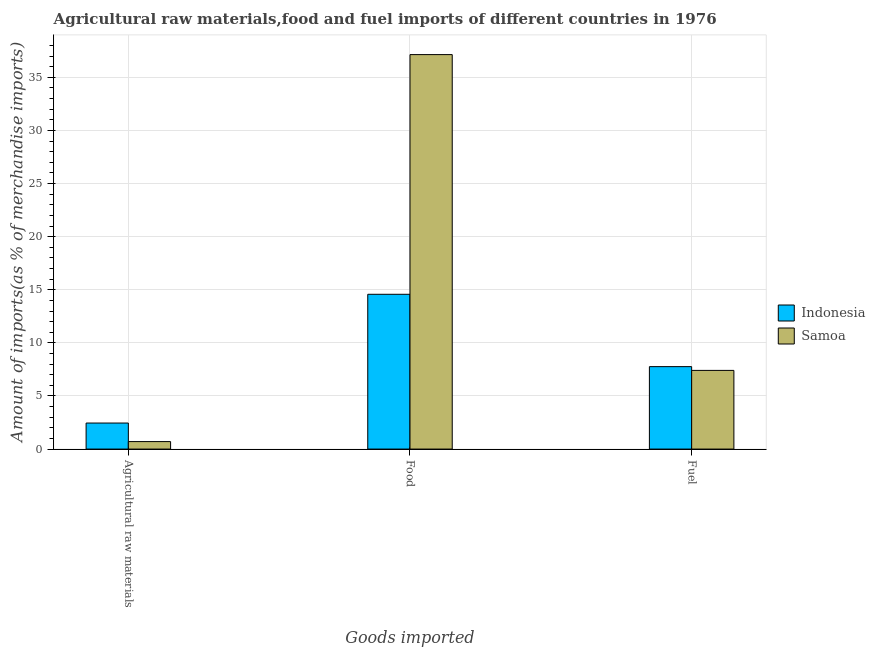How many different coloured bars are there?
Your response must be concise. 2. How many groups of bars are there?
Provide a short and direct response. 3. Are the number of bars per tick equal to the number of legend labels?
Make the answer very short. Yes. How many bars are there on the 2nd tick from the right?
Keep it short and to the point. 2. What is the label of the 2nd group of bars from the left?
Provide a short and direct response. Food. What is the percentage of fuel imports in Samoa?
Provide a short and direct response. 7.41. Across all countries, what is the maximum percentage of raw materials imports?
Provide a short and direct response. 2.45. Across all countries, what is the minimum percentage of fuel imports?
Your answer should be very brief. 7.41. In which country was the percentage of food imports maximum?
Offer a very short reply. Samoa. In which country was the percentage of fuel imports minimum?
Offer a very short reply. Samoa. What is the total percentage of fuel imports in the graph?
Give a very brief answer. 15.17. What is the difference between the percentage of raw materials imports in Samoa and that in Indonesia?
Your response must be concise. -1.75. What is the difference between the percentage of raw materials imports in Samoa and the percentage of fuel imports in Indonesia?
Offer a very short reply. -7.06. What is the average percentage of fuel imports per country?
Your response must be concise. 7.58. What is the difference between the percentage of food imports and percentage of fuel imports in Indonesia?
Make the answer very short. 6.81. What is the ratio of the percentage of food imports in Samoa to that in Indonesia?
Provide a short and direct response. 2.55. Is the percentage of raw materials imports in Indonesia less than that in Samoa?
Ensure brevity in your answer.  No. What is the difference between the highest and the second highest percentage of food imports?
Offer a terse response. 22.57. What is the difference between the highest and the lowest percentage of food imports?
Provide a short and direct response. 22.57. In how many countries, is the percentage of fuel imports greater than the average percentage of fuel imports taken over all countries?
Make the answer very short. 1. Is the sum of the percentage of food imports in Indonesia and Samoa greater than the maximum percentage of raw materials imports across all countries?
Your answer should be compact. Yes. What does the 2nd bar from the left in Fuel represents?
Your response must be concise. Samoa. What does the 1st bar from the right in Food represents?
Provide a short and direct response. Samoa. How many bars are there?
Give a very brief answer. 6. What is the difference between two consecutive major ticks on the Y-axis?
Make the answer very short. 5. Are the values on the major ticks of Y-axis written in scientific E-notation?
Offer a very short reply. No. Does the graph contain grids?
Provide a succinct answer. Yes. Where does the legend appear in the graph?
Your response must be concise. Center right. How many legend labels are there?
Keep it short and to the point. 2. How are the legend labels stacked?
Your answer should be compact. Vertical. What is the title of the graph?
Your response must be concise. Agricultural raw materials,food and fuel imports of different countries in 1976. What is the label or title of the X-axis?
Keep it short and to the point. Goods imported. What is the label or title of the Y-axis?
Your response must be concise. Amount of imports(as % of merchandise imports). What is the Amount of imports(as % of merchandise imports) in Indonesia in Agricultural raw materials?
Give a very brief answer. 2.45. What is the Amount of imports(as % of merchandise imports) of Samoa in Agricultural raw materials?
Keep it short and to the point. 0.7. What is the Amount of imports(as % of merchandise imports) of Indonesia in Food?
Offer a terse response. 14.57. What is the Amount of imports(as % of merchandise imports) in Samoa in Food?
Offer a terse response. 37.14. What is the Amount of imports(as % of merchandise imports) of Indonesia in Fuel?
Your answer should be compact. 7.76. What is the Amount of imports(as % of merchandise imports) of Samoa in Fuel?
Make the answer very short. 7.41. Across all Goods imported, what is the maximum Amount of imports(as % of merchandise imports) in Indonesia?
Make the answer very short. 14.57. Across all Goods imported, what is the maximum Amount of imports(as % of merchandise imports) of Samoa?
Make the answer very short. 37.14. Across all Goods imported, what is the minimum Amount of imports(as % of merchandise imports) of Indonesia?
Make the answer very short. 2.45. Across all Goods imported, what is the minimum Amount of imports(as % of merchandise imports) of Samoa?
Offer a terse response. 0.7. What is the total Amount of imports(as % of merchandise imports) of Indonesia in the graph?
Your answer should be very brief. 24.79. What is the total Amount of imports(as % of merchandise imports) in Samoa in the graph?
Your answer should be compact. 45.25. What is the difference between the Amount of imports(as % of merchandise imports) in Indonesia in Agricultural raw materials and that in Food?
Ensure brevity in your answer.  -12.12. What is the difference between the Amount of imports(as % of merchandise imports) in Samoa in Agricultural raw materials and that in Food?
Ensure brevity in your answer.  -36.44. What is the difference between the Amount of imports(as % of merchandise imports) in Indonesia in Agricultural raw materials and that in Fuel?
Provide a succinct answer. -5.31. What is the difference between the Amount of imports(as % of merchandise imports) in Samoa in Agricultural raw materials and that in Fuel?
Offer a terse response. -6.7. What is the difference between the Amount of imports(as % of merchandise imports) in Indonesia in Food and that in Fuel?
Your answer should be very brief. 6.81. What is the difference between the Amount of imports(as % of merchandise imports) in Samoa in Food and that in Fuel?
Your answer should be very brief. 29.73. What is the difference between the Amount of imports(as % of merchandise imports) of Indonesia in Agricultural raw materials and the Amount of imports(as % of merchandise imports) of Samoa in Food?
Keep it short and to the point. -34.69. What is the difference between the Amount of imports(as % of merchandise imports) of Indonesia in Agricultural raw materials and the Amount of imports(as % of merchandise imports) of Samoa in Fuel?
Ensure brevity in your answer.  -4.96. What is the difference between the Amount of imports(as % of merchandise imports) in Indonesia in Food and the Amount of imports(as % of merchandise imports) in Samoa in Fuel?
Offer a terse response. 7.17. What is the average Amount of imports(as % of merchandise imports) in Indonesia per Goods imported?
Provide a short and direct response. 8.26. What is the average Amount of imports(as % of merchandise imports) in Samoa per Goods imported?
Ensure brevity in your answer.  15.08. What is the difference between the Amount of imports(as % of merchandise imports) of Indonesia and Amount of imports(as % of merchandise imports) of Samoa in Agricultural raw materials?
Provide a succinct answer. 1.75. What is the difference between the Amount of imports(as % of merchandise imports) in Indonesia and Amount of imports(as % of merchandise imports) in Samoa in Food?
Your answer should be compact. -22.57. What is the difference between the Amount of imports(as % of merchandise imports) in Indonesia and Amount of imports(as % of merchandise imports) in Samoa in Fuel?
Offer a terse response. 0.36. What is the ratio of the Amount of imports(as % of merchandise imports) of Indonesia in Agricultural raw materials to that in Food?
Provide a succinct answer. 0.17. What is the ratio of the Amount of imports(as % of merchandise imports) of Samoa in Agricultural raw materials to that in Food?
Offer a very short reply. 0.02. What is the ratio of the Amount of imports(as % of merchandise imports) in Indonesia in Agricultural raw materials to that in Fuel?
Make the answer very short. 0.32. What is the ratio of the Amount of imports(as % of merchandise imports) in Samoa in Agricultural raw materials to that in Fuel?
Provide a succinct answer. 0.1. What is the ratio of the Amount of imports(as % of merchandise imports) in Indonesia in Food to that in Fuel?
Give a very brief answer. 1.88. What is the ratio of the Amount of imports(as % of merchandise imports) of Samoa in Food to that in Fuel?
Ensure brevity in your answer.  5.01. What is the difference between the highest and the second highest Amount of imports(as % of merchandise imports) in Indonesia?
Your answer should be very brief. 6.81. What is the difference between the highest and the second highest Amount of imports(as % of merchandise imports) of Samoa?
Your answer should be compact. 29.73. What is the difference between the highest and the lowest Amount of imports(as % of merchandise imports) of Indonesia?
Make the answer very short. 12.12. What is the difference between the highest and the lowest Amount of imports(as % of merchandise imports) of Samoa?
Ensure brevity in your answer.  36.44. 